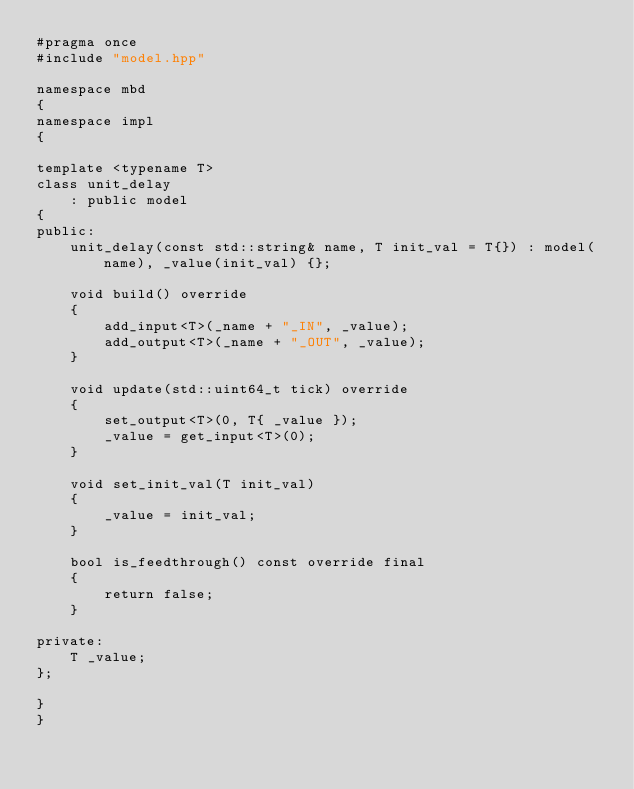<code> <loc_0><loc_0><loc_500><loc_500><_C++_>#pragma once
#include "model.hpp"

namespace mbd
{
namespace impl
{

template <typename T>
class unit_delay
	: public model
{
public:
	unit_delay(const std::string& name, T init_val = T{}) : model(name), _value(init_val) {};

	void build() override
	{
		add_input<T>(_name + "_IN", _value);
		add_output<T>(_name + "_OUT", _value);
	}

	void update(std::uint64_t tick) override
	{
		set_output<T>(0, T{ _value });
		_value = get_input<T>(0);
	}

	void set_init_val(T init_val)
	{
		_value = init_val;
	}

	bool is_feedthrough() const override final
	{
		return false;
	}

private:
	T _value;
};

}
}</code> 